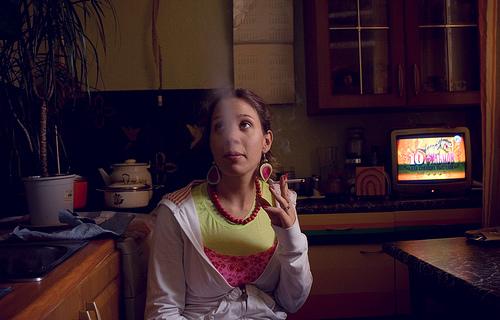How many glasses are on the counter?
Short answer required. 0. What room is the woman in?
Be succinct. Kitchen. Is this outdoors?
Quick response, please. No. What color is the photo?
Concise answer only. Brown. What is the woman wearing around her neck?
Keep it brief. Necklace. Is there a lot of drinks on the table?
Short answer required. No. Is the woman acting like Norman Bates?
Write a very short answer. No. What time of year is it?
Write a very short answer. Winter. How many people are there?
Keep it brief. 1. What color is the woman's robe?
Write a very short answer. White. Is the girl playing?
Write a very short answer. No. How many girls are sitting down?
Be succinct. 1. IS this a child?
Answer briefly. No. What is on in the background?
Concise answer only. Tv. What are the displays celebrating?
Keep it brief. Nothing. What color are the dots on the pink dress?
Short answer required. Red. What is the brown object next to the girl?
Write a very short answer. Counter. Is there anyone looking?
Concise answer only. No. What is the person holding?
Answer briefly. Cigarette. What type of top is the woman wearing?
Be succinct. Hoodie. Are the people in a living room?
Keep it brief. No. What game system is this woman using?
Quick response, please. None. How old is this picture?
Short answer required. 10 years. How was her sweater made?
Short answer required. Machine. What room is this?
Short answer required. Kitchen. What year was this taken?
Give a very brief answer. 2010. What is in her hand?
Answer briefly. Cigarette. What is the person's gender?
Quick response, please. Female. Is it sunny in the image?
Write a very short answer. No. 